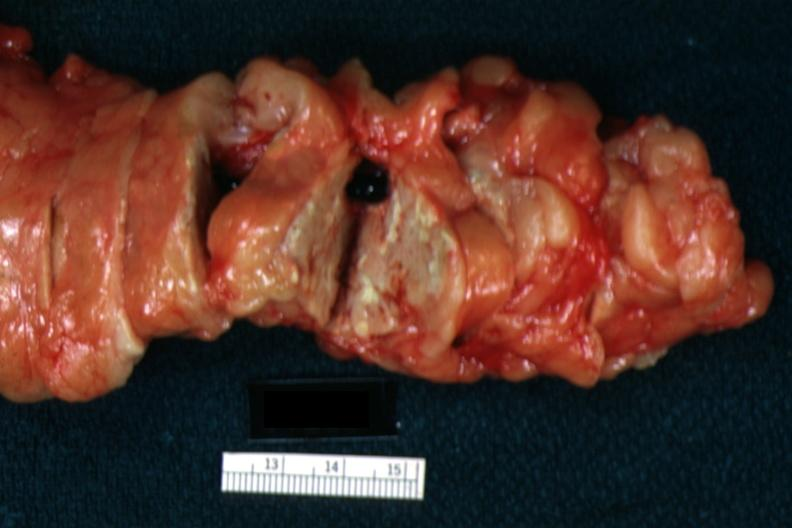s cephalothoracopagus janiceps present?
Answer the question using a single word or phrase. No 